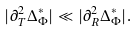<formula> <loc_0><loc_0><loc_500><loc_500>| \partial _ { T } ^ { 2 } { \Delta } ^ { * } _ { \Phi } | \ll | \partial _ { R } ^ { 2 } { \Delta } ^ { * } _ { \Phi } | .</formula> 